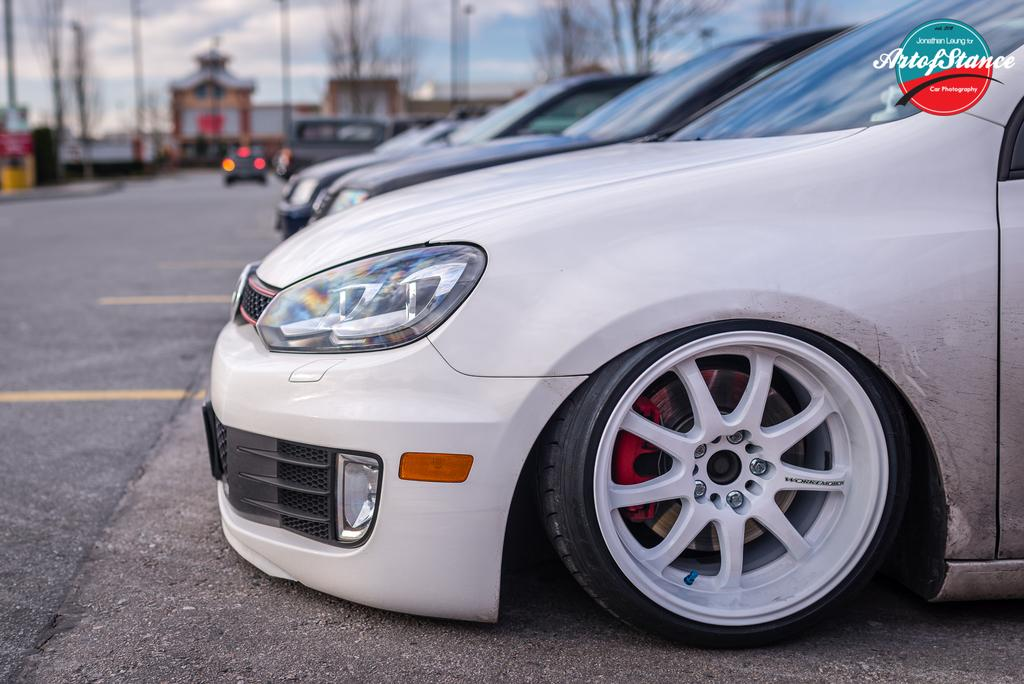What can be seen on the right side of the image? There are cars on a road on the right side of the image. What is visible in the background of the image? There are trees, at least one building, and the sky visible in the background of the image. How is the image quality? The image is blurred. Is there any additional information or branding in the image? Yes, there is a logo in the top right corner of the image. Can you see a pot being used to unlock a door in the image? There is no pot or door visible in the image, and therefore no such activity can be observed. What type of sponge is being used to clean the cars in the image? There is no sponge present in the image; the cars are not being cleaned. 